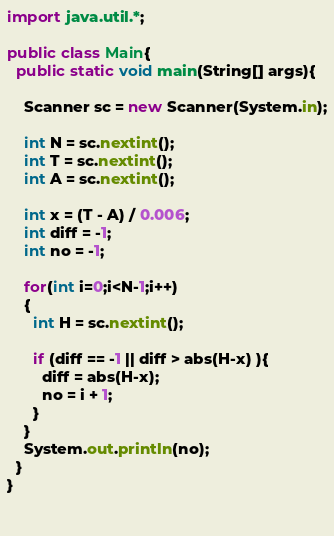Convert code to text. <code><loc_0><loc_0><loc_500><loc_500><_Java_>import java.util.*;

public class Main{
  public static void main(String[] args){
    
    Scanner sc = new Scanner(System.in);
    
    int N = sc.nextint();
    int T = sc.nextint();
    int A = sc.nextint();
    
    int x = (T - A) / 0.006;
    int diff = -1;
    int no = -1;
    
    for(int i=0;i<N-1;i++)
    {
      int H = sc.nextint();
      
      if (diff == -1 || diff > abs(H-x) ){
        diff = abs(H-x);
        no = i + 1;
      }
    }
    System.out.println(no);
  }
}

    </code> 